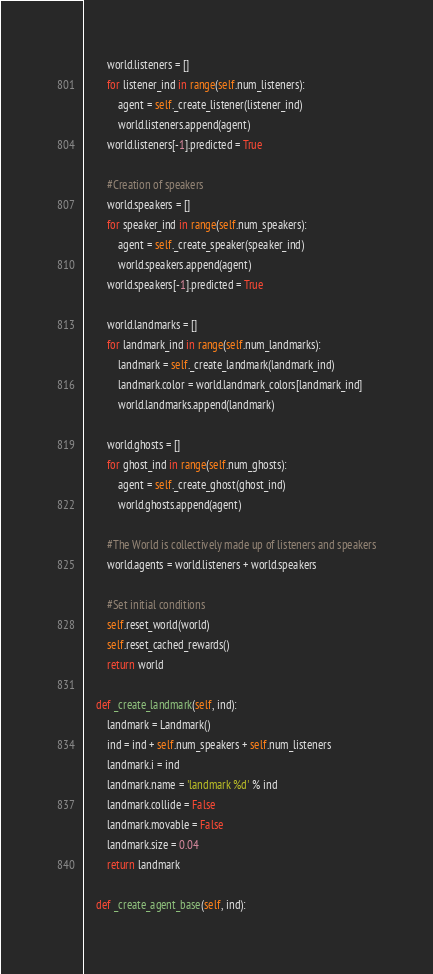Convert code to text. <code><loc_0><loc_0><loc_500><loc_500><_Python_>        world.listeners = []
        for listener_ind in range(self.num_listeners):
            agent = self._create_listener(listener_ind)
            world.listeners.append(agent)
        world.listeners[-1].predicted = True

        #Creation of speakers
        world.speakers = []
        for speaker_ind in range(self.num_speakers):
            agent = self._create_speaker(speaker_ind)
            world.speakers.append(agent)
        world.speakers[-1].predicted = True

        world.landmarks = []
        for landmark_ind in range(self.num_landmarks):
            landmark = self._create_landmark(landmark_ind)
            landmark.color = world.landmark_colors[landmark_ind]
            world.landmarks.append(landmark)

        world.ghosts = []
        for ghost_ind in range(self.num_ghosts):
            agent = self._create_ghost(ghost_ind)
            world.ghosts.append(agent)

        #The World is collectively made up of listeners and speakers
        world.agents = world.listeners + world.speakers

        #Set initial conditions
        self.reset_world(world)
        self.reset_cached_rewards()
        return world

    def _create_landmark(self, ind):
        landmark = Landmark()
        ind = ind + self.num_speakers + self.num_listeners
        landmark.i = ind
        landmark.name = 'landmark %d' % ind
        landmark.collide = False
        landmark.movable = False
        landmark.size = 0.04
        return landmark

    def _create_agent_base(self, ind):</code> 